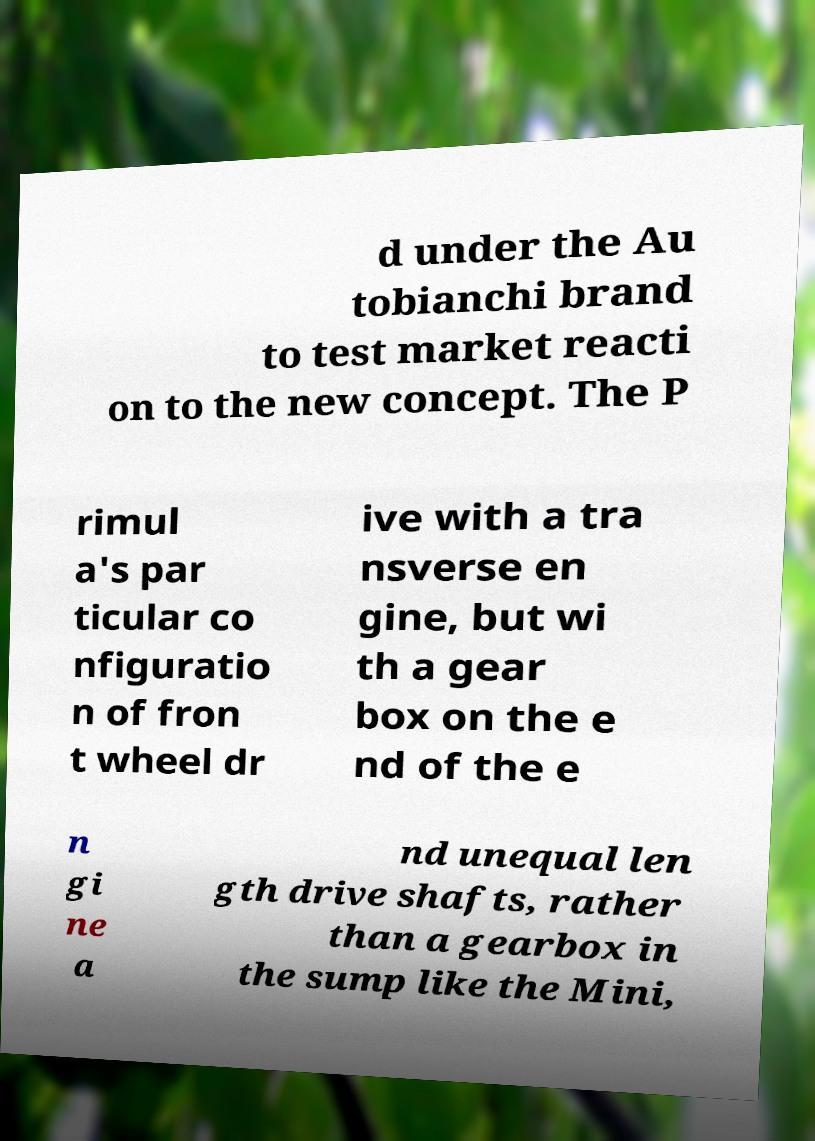Can you accurately transcribe the text from the provided image for me? d under the Au tobianchi brand to test market reacti on to the new concept. The P rimul a's par ticular co nfiguratio n of fron t wheel dr ive with a tra nsverse en gine, but wi th a gear box on the e nd of the e n gi ne a nd unequal len gth drive shafts, rather than a gearbox in the sump like the Mini, 